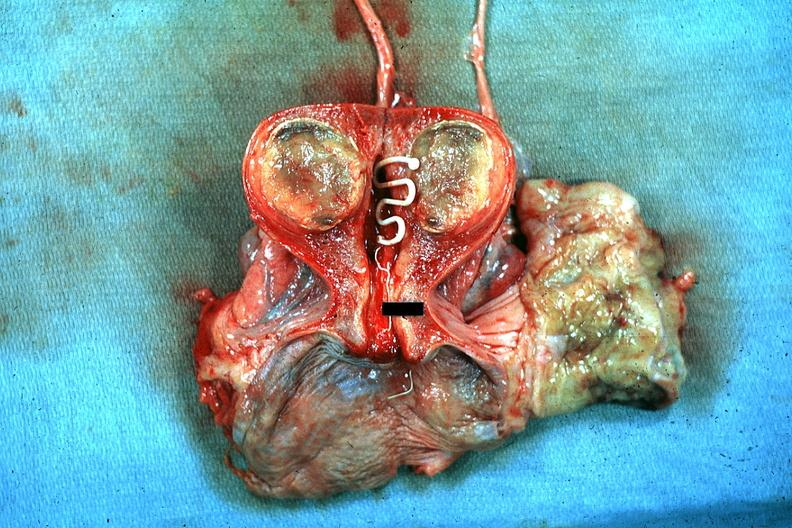what is present?
Answer the question using a single word or phrase. Uterus 